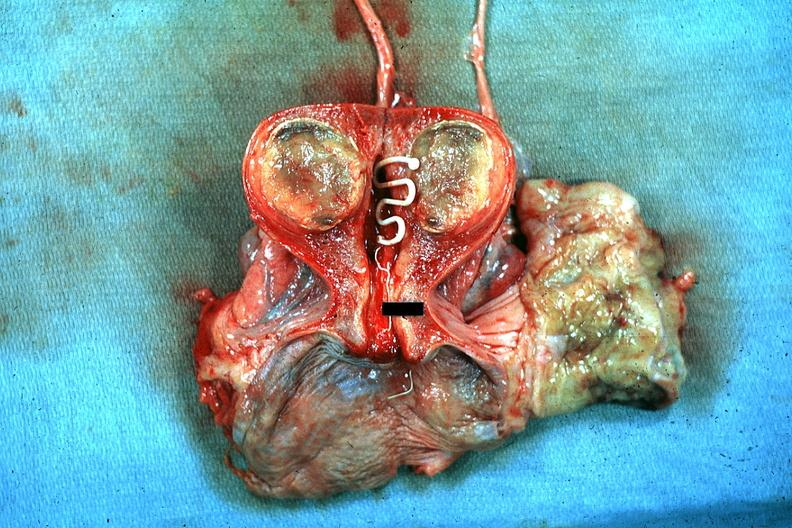what is present?
Answer the question using a single word or phrase. Uterus 